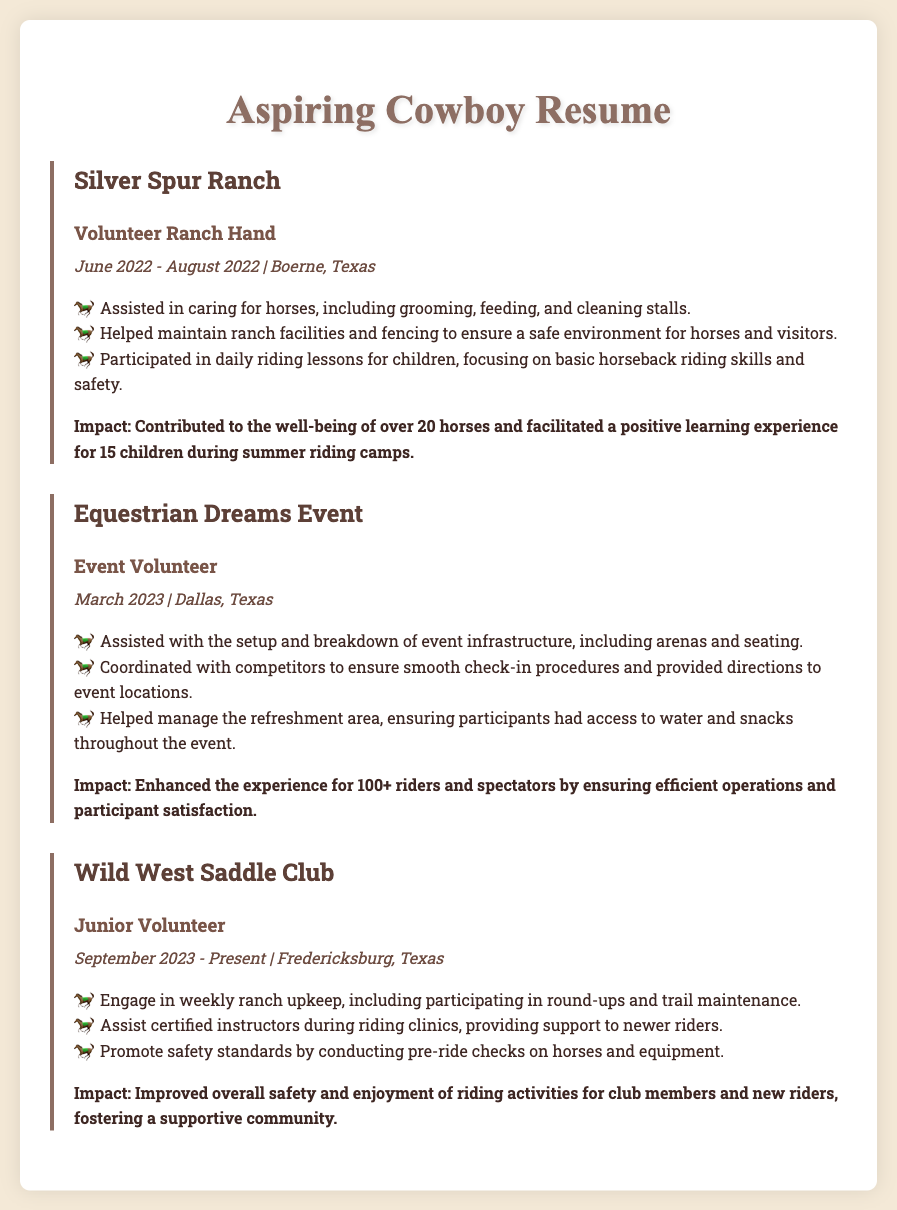What is the name of the ranch where the first volunteer experience took place? The document states that the first volunteer experience was at Silver Spur Ranch.
Answer: Silver Spur Ranch During which month and year did the Equestrian Dreams Event occur? The document lists that the Equestrian Dreams Event took place in March 2023.
Answer: March 2023 What was one of the responsibilities at Silver Spur Ranch? The document mentions assisting in caring for horses as one of the responsibilities.
Answer: Caring for horses How many horses were positively impacted at Silver Spur Ranch? The impact section states that over 20 horses were positively impacted during the volunteer experience.
Answer: Over 20 horses What role does the Junior Volunteer at Wild West Saddle Club perform? The document indicates that the Junior Volunteer assists certified instructors during riding clinics.
Answer: Assisting instructors How many participants did the Equestrian Dreams Event enhance the experience for? According to the impact section, the event enhanced the experience for 100+ riders and spectators.
Answer: 100+ What city is the Silver Spur Ranch located in? The document specifies that Silver Spur Ranch is located in Boerne, Texas.
Answer: Boerne, Texas What is the primary focus of the activities at the Wild West Saddle Club? The document suggests that the activities focus on ranch upkeep and supporting newer riders.
Answer: Ranch upkeep and supporting newer riders What type of document is this? The structure and content indicate that this document is a resume.
Answer: Resume 